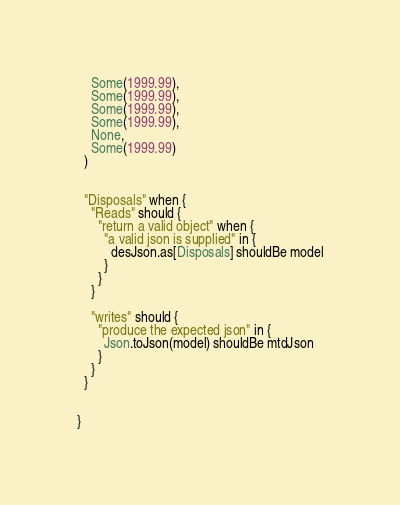Convert code to text. <code><loc_0><loc_0><loc_500><loc_500><_Scala_>    Some(1999.99),
    Some(1999.99),
    Some(1999.99),
    Some(1999.99),
    None,
    Some(1999.99)
  )


  "Disposals" when {
    "Reads" should {
      "return a valid object" when {
        "a valid json is supplied" in {
          desJson.as[Disposals] shouldBe model
        }
      }
    }

    "writes" should {
      "produce the expected json" in {
        Json.toJson(model) shouldBe mtdJson
      }
    }
  }


}
</code> 